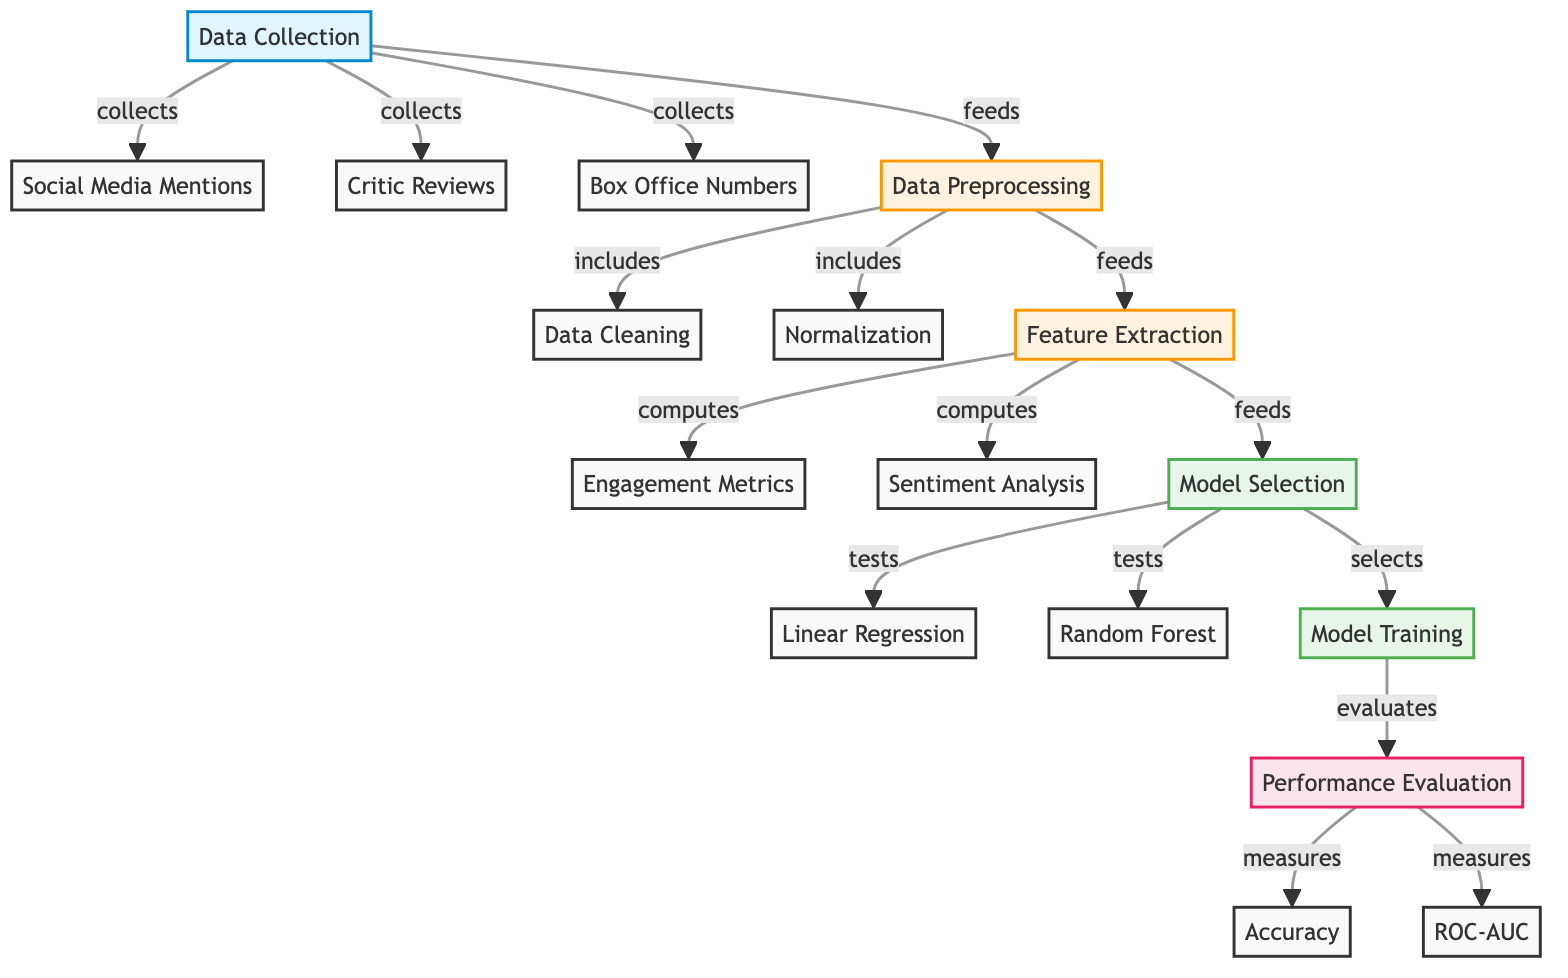What elements contribute to data collection? The data collection node points to three elements: social media mentions, critic reviews, and box office numbers, indicating that these are the components collected for analysis.
Answer: social media mentions, critic reviews, box office numbers How many processes are involved in the data preprocessing stage? The preprocessing node includes two specific processes: data cleaning and normalization; therefore, there are two processes involved in this step.
Answer: 2 Which modeling technique is tested after model selection? The model selection node indicates that two modeling techniques are tested: linear regression and random forest, and the question asks specifically for the techniques tested.
Answer: linear regression, random forest What is the final step of the diagram? The flow of the diagram culminates in performance evaluation where it measures accuracy and ROC-AUC, thus the last process is related to performance evaluation.
Answer: performance evaluation What type of metrics are computed during feature extraction? The feature extraction node shows that engagement metrics and sentiment analysis are computed, indicating the types of metrics derived at this stage.
Answer: engagement metrics, sentiment analysis What happens after the model training step? The model training step leads to performance evaluation, showing that the output of training informs the evaluation phase of the model.
Answer: performance evaluation Which stage precedes feature extraction? The diagram flow indicates that data preprocessing directly feeds into feature extraction, making preprocessing the stage prior to feature extraction.
Answer: data preprocessing 